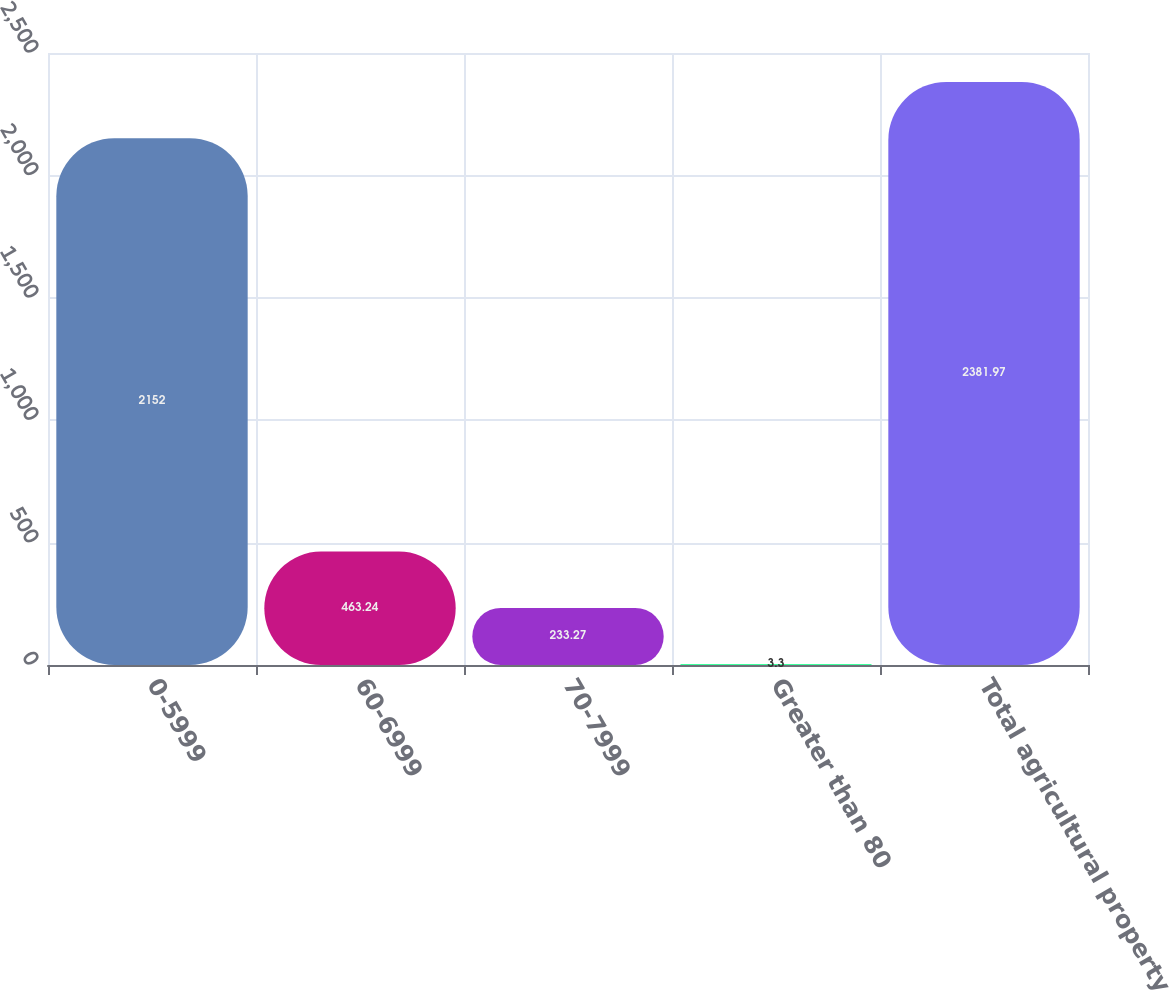Convert chart. <chart><loc_0><loc_0><loc_500><loc_500><bar_chart><fcel>0-5999<fcel>60-6999<fcel>70-7999<fcel>Greater than 80<fcel>Total agricultural property<nl><fcel>2152<fcel>463.24<fcel>233.27<fcel>3.3<fcel>2381.97<nl></chart> 